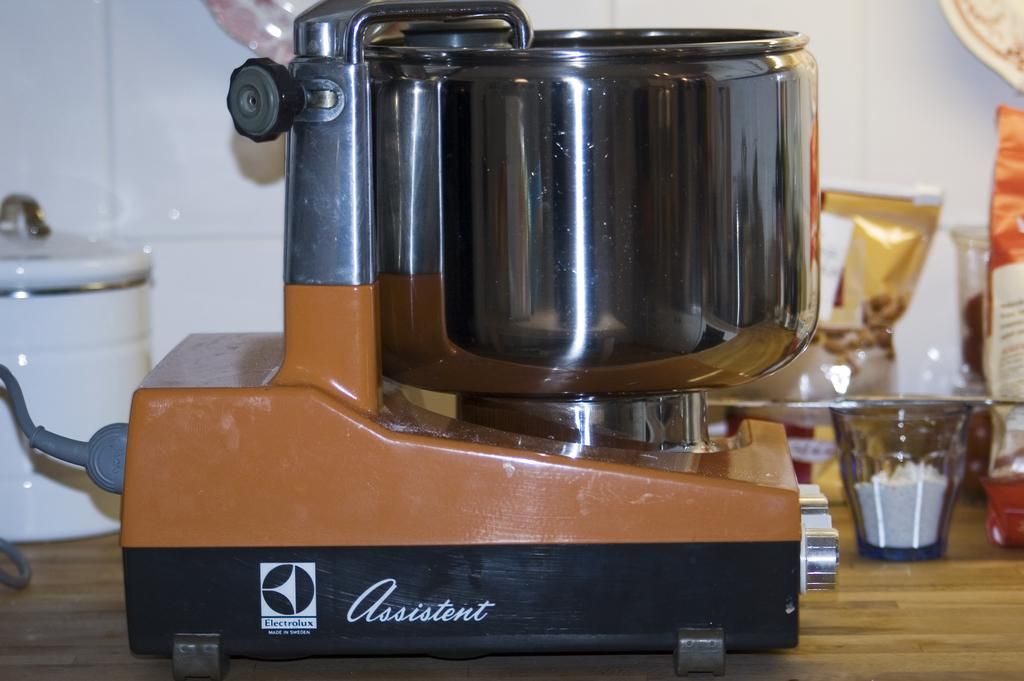<image>
Summarize the visual content of the image. A machine for food preparation is imprinted with the name "assistent" on the side. 